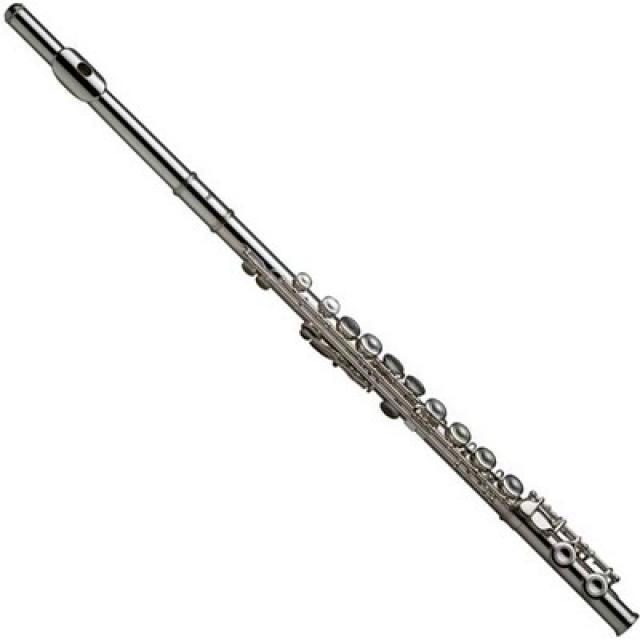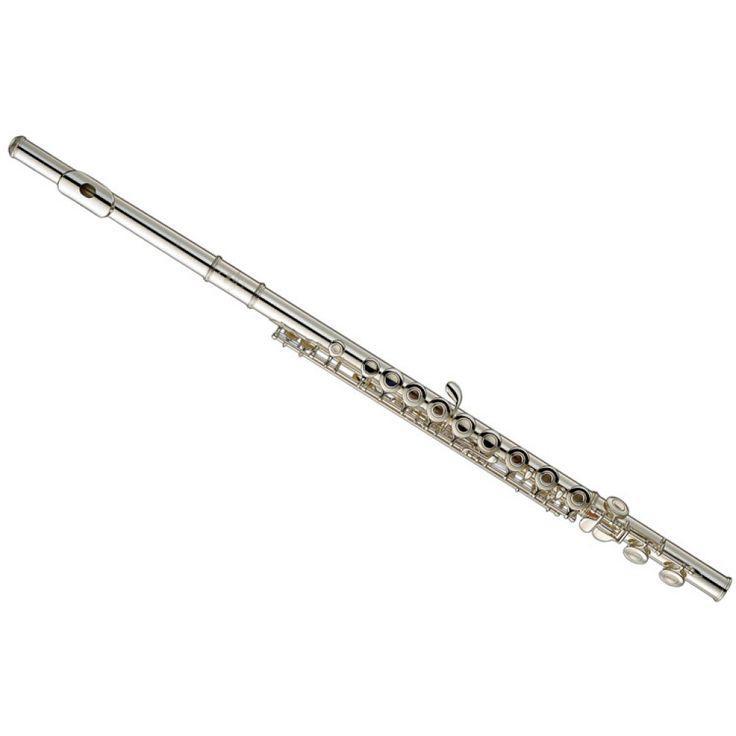The first image is the image on the left, the second image is the image on the right. Given the left and right images, does the statement "There are exactly two assembled flutes." hold true? Answer yes or no. Yes. The first image is the image on the left, the second image is the image on the right. Analyze the images presented: Is the assertion "There are at least two metal wind instruments." valid? Answer yes or no. Yes. 